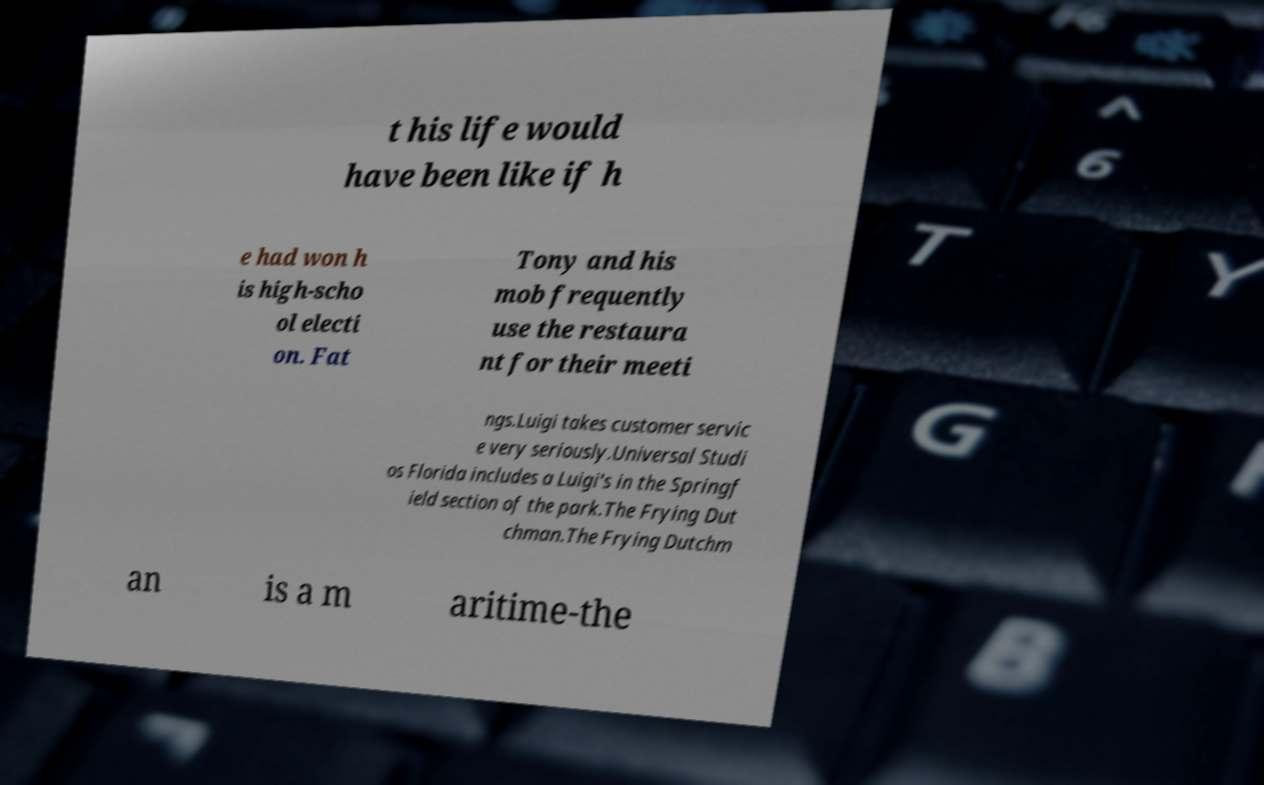Can you read and provide the text displayed in the image?This photo seems to have some interesting text. Can you extract and type it out for me? t his life would have been like if h e had won h is high-scho ol electi on. Fat Tony and his mob frequently use the restaura nt for their meeti ngs.Luigi takes customer servic e very seriously.Universal Studi os Florida includes a Luigi's in the Springf ield section of the park.The Frying Dut chman.The Frying Dutchm an is a m aritime-the 